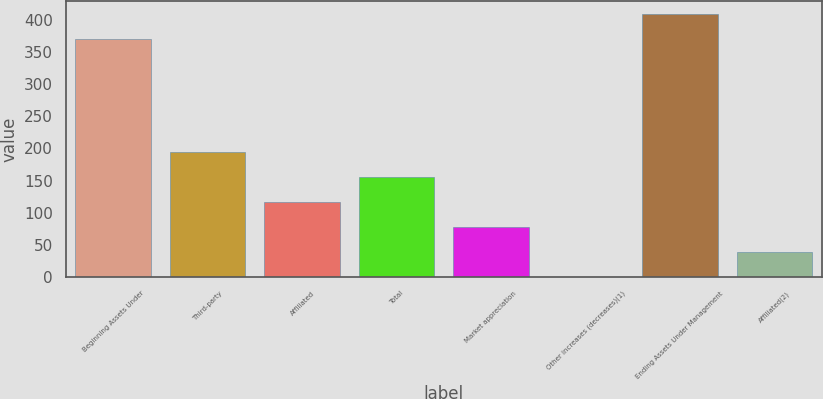<chart> <loc_0><loc_0><loc_500><loc_500><bar_chart><fcel>Beginning Assets Under<fcel>Third-party<fcel>Affiliated<fcel>Total<fcel>Market appreciation<fcel>Other increases (decreases)(1)<fcel>Ending Assets Under Management<fcel>Affiliated(2)<nl><fcel>370<fcel>194.6<fcel>116.8<fcel>155.7<fcel>77.9<fcel>0.1<fcel>408.9<fcel>39<nl></chart> 